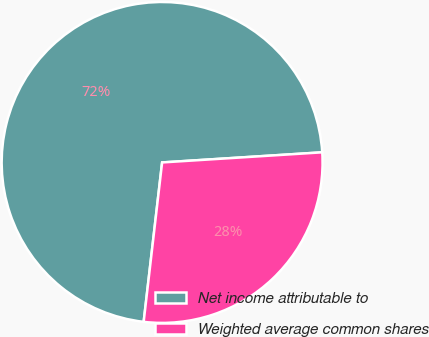Convert chart to OTSL. <chart><loc_0><loc_0><loc_500><loc_500><pie_chart><fcel>Net income attributable to<fcel>Weighted average common shares<nl><fcel>72.16%<fcel>27.84%<nl></chart> 